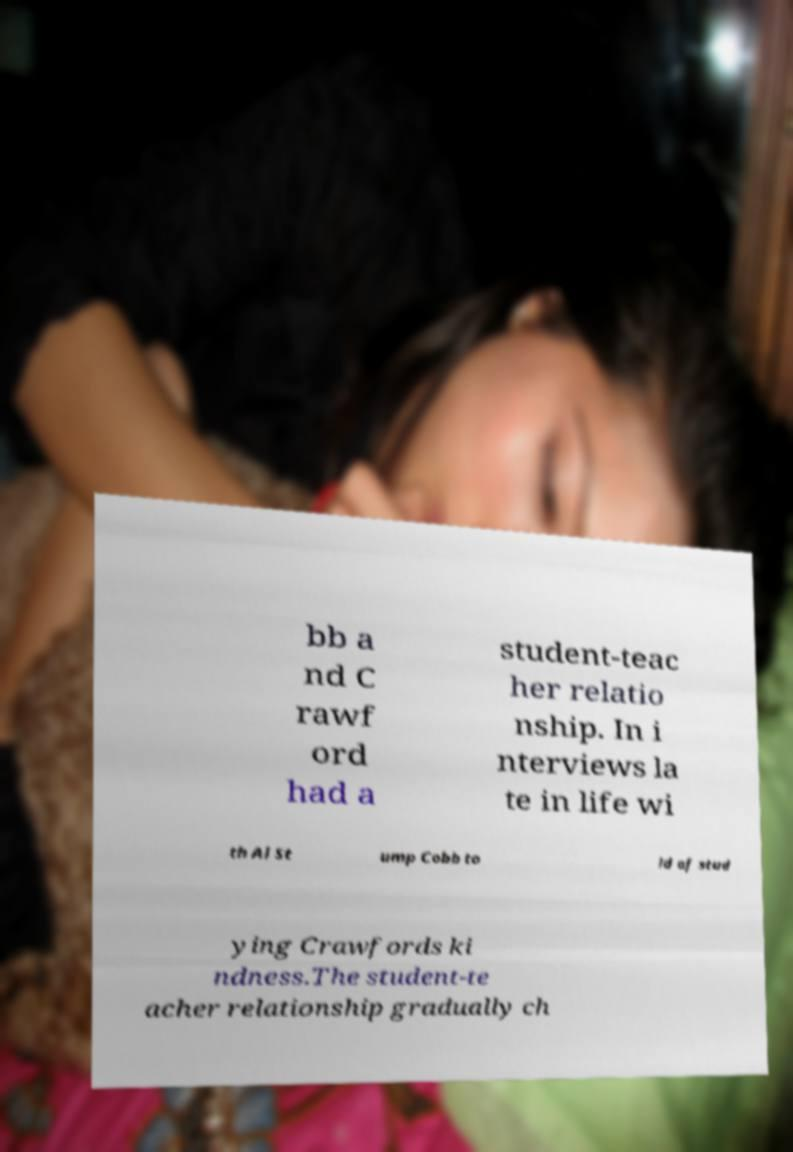Could you extract and type out the text from this image? bb a nd C rawf ord had a student-teac her relatio nship. In i nterviews la te in life wi th Al St ump Cobb to ld of stud ying Crawfords ki ndness.The student-te acher relationship gradually ch 